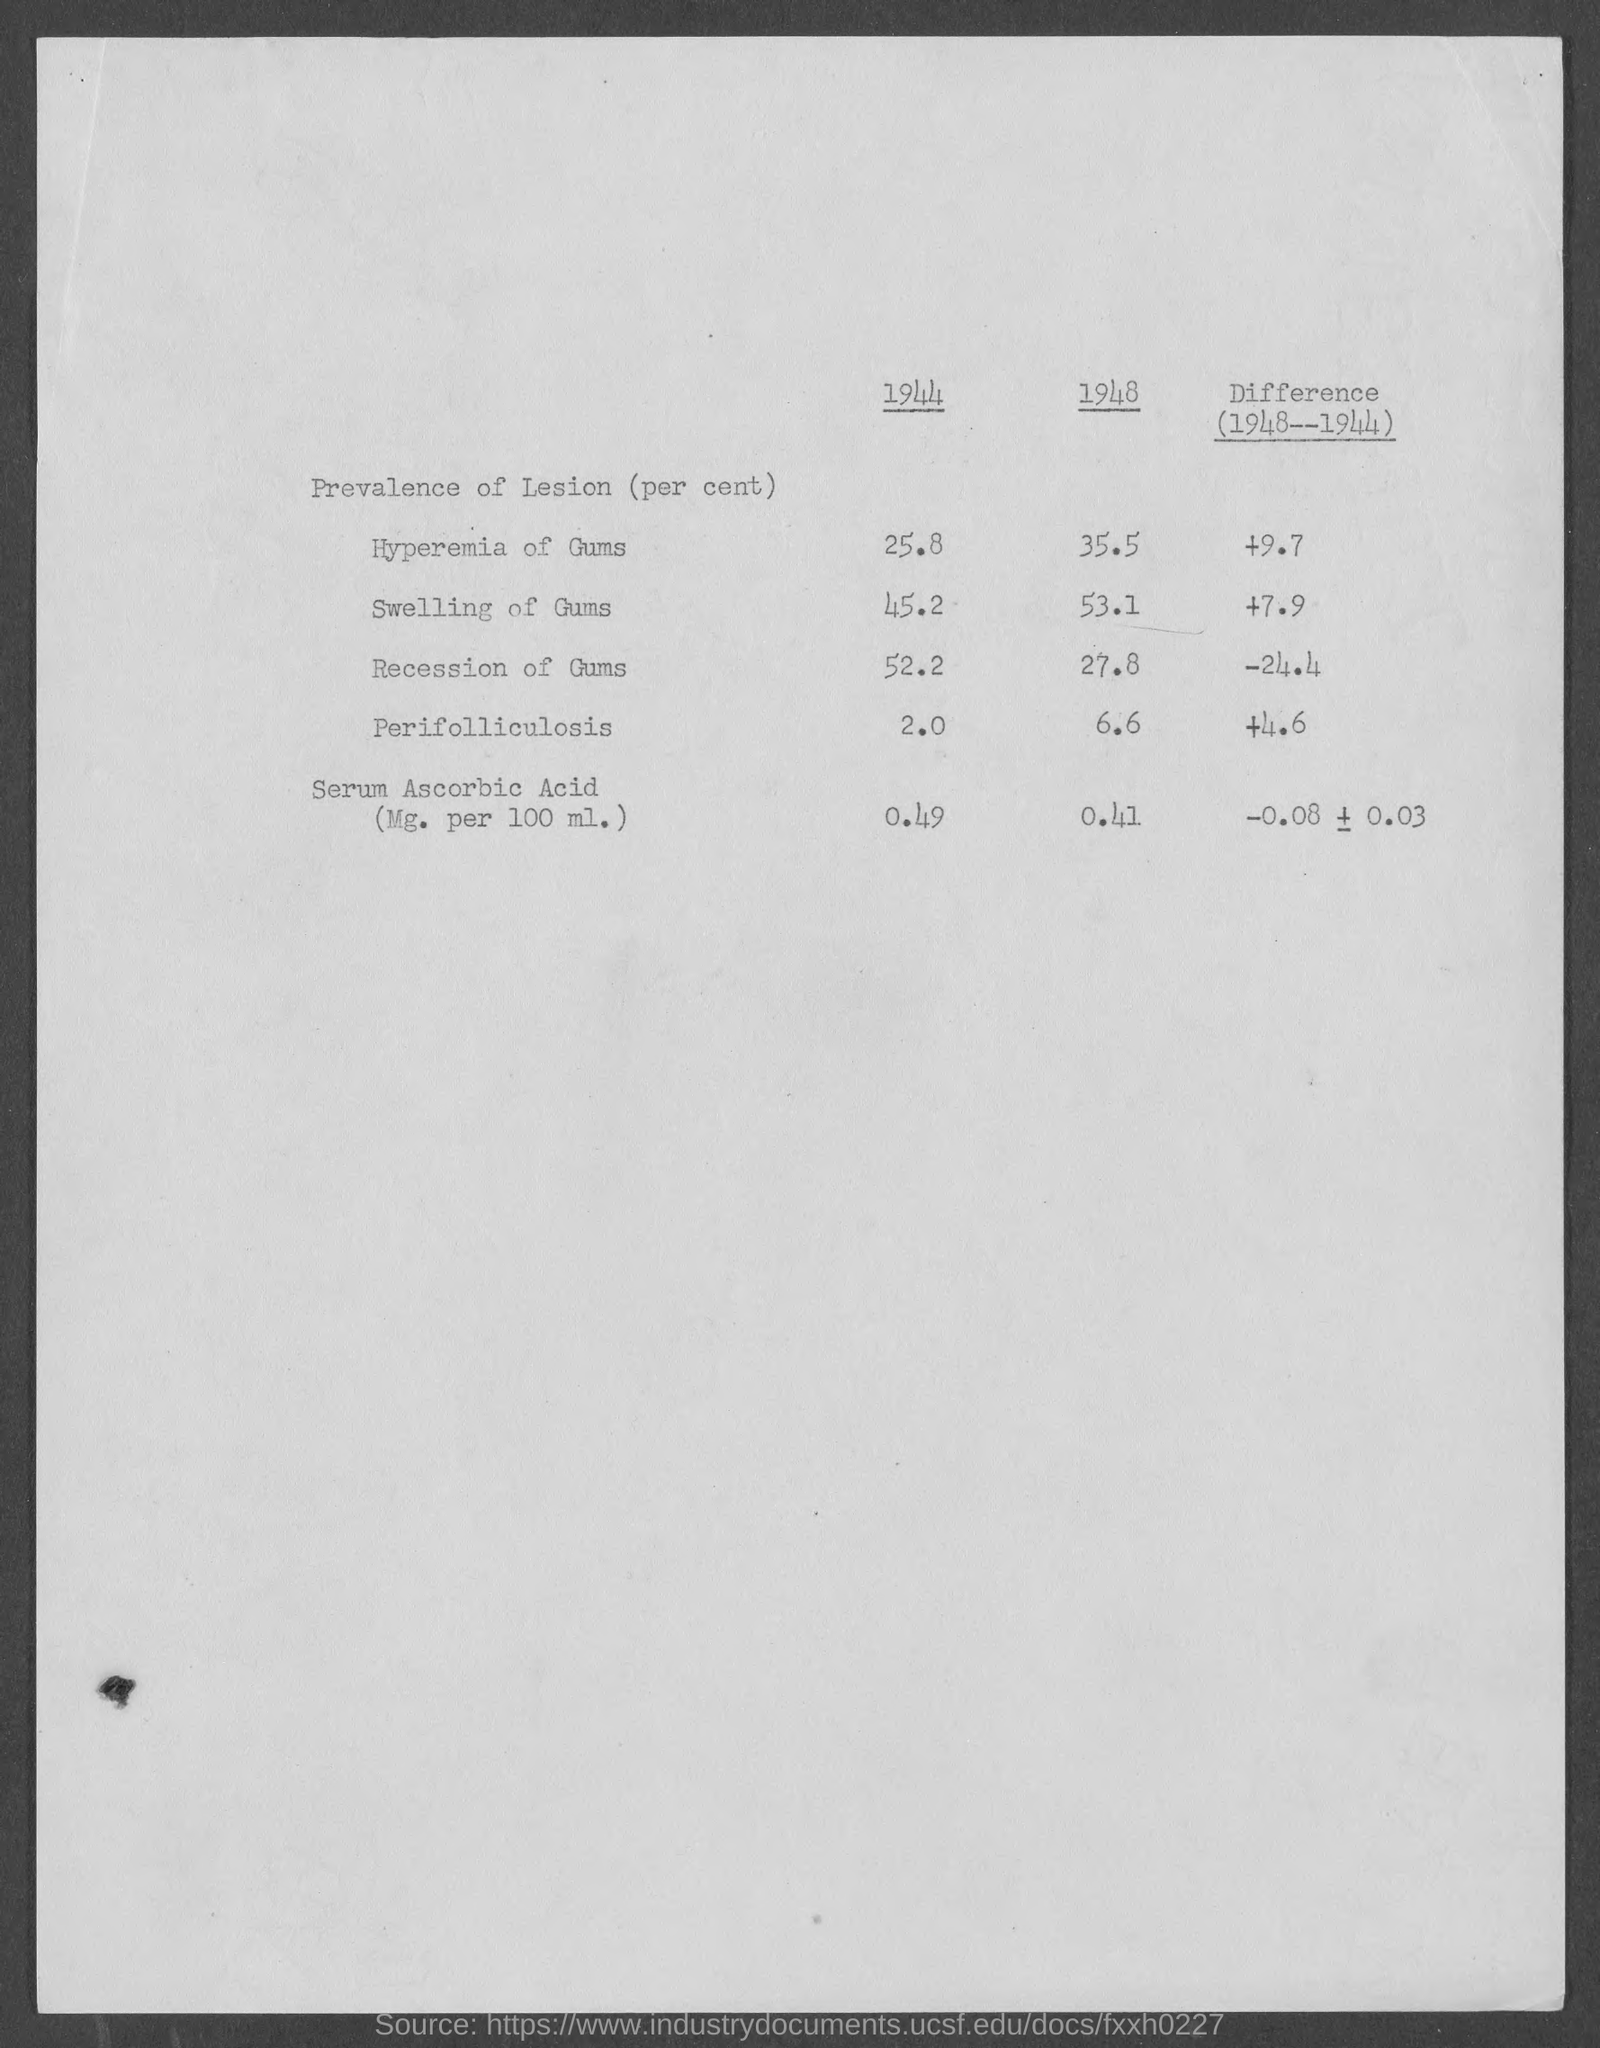What percent is the prevalence of lesion in Hyperemia of Gums in the year 1944?
Your answer should be compact. 25.8. What percent is the prevalence of lesion in Perifolliculosis in the year 1948?
Offer a terse response. 6.6. What is the difference (1948-1944) in the prevalence of lesion (Percent) in Recession of Gums?
Keep it short and to the point. -24.4. What percent is the prevalence of lesion in Serum Ascorbic Acid in the year 1948?
Provide a short and direct response. 0.41. 